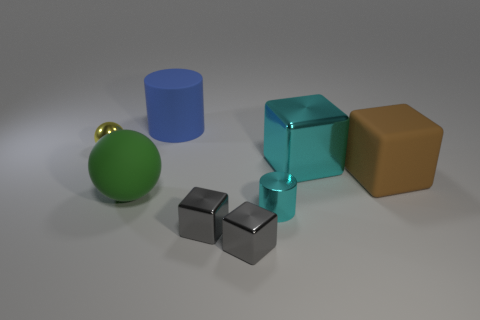Subtract all gray blocks. Subtract all gray cylinders. How many blocks are left? 2 Add 1 large shiny cubes. How many objects exist? 9 Subtract all balls. How many objects are left? 6 Add 5 green balls. How many green balls are left? 6 Add 7 big cylinders. How many big cylinders exist? 8 Subtract 1 gray cubes. How many objects are left? 7 Subtract all tiny shiny cubes. Subtract all cyan metal blocks. How many objects are left? 5 